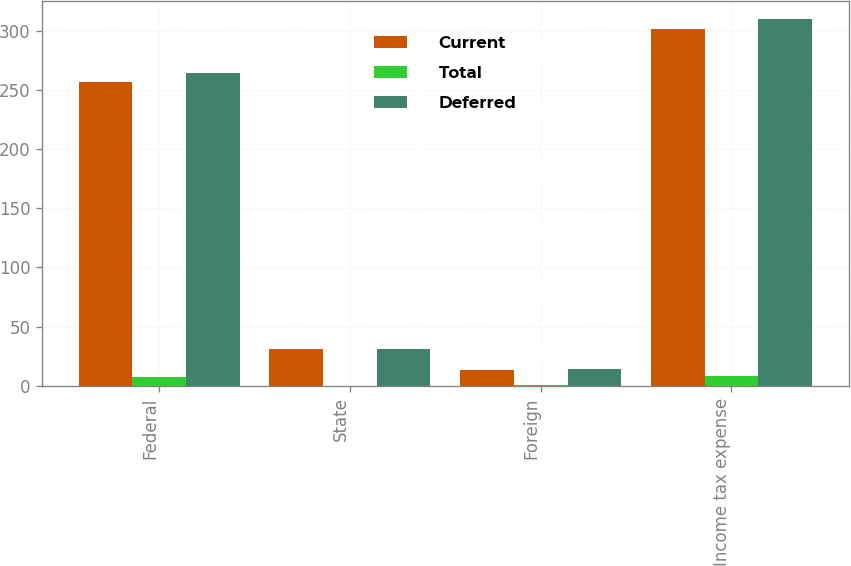<chart> <loc_0><loc_0><loc_500><loc_500><stacked_bar_chart><ecel><fcel>Federal<fcel>State<fcel>Foreign<fcel>Income tax expense<nl><fcel>Current<fcel>256.7<fcel>31.3<fcel>13.7<fcel>301.7<nl><fcel>Total<fcel>7.4<fcel>0.2<fcel>0.4<fcel>8<nl><fcel>Deferred<fcel>264.1<fcel>31.5<fcel>14.1<fcel>309.7<nl></chart> 